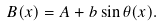<formula> <loc_0><loc_0><loc_500><loc_500>B ( x ) = A + b \sin { \theta ( x ) } .</formula> 